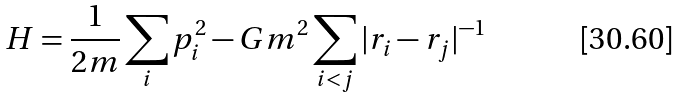<formula> <loc_0><loc_0><loc_500><loc_500>H = \frac { 1 } { 2 m } \sum _ { i } p _ { i } ^ { 2 } - G m ^ { 2 } \sum _ { i < j } | r _ { i } - r _ { j } | ^ { - 1 }</formula> 